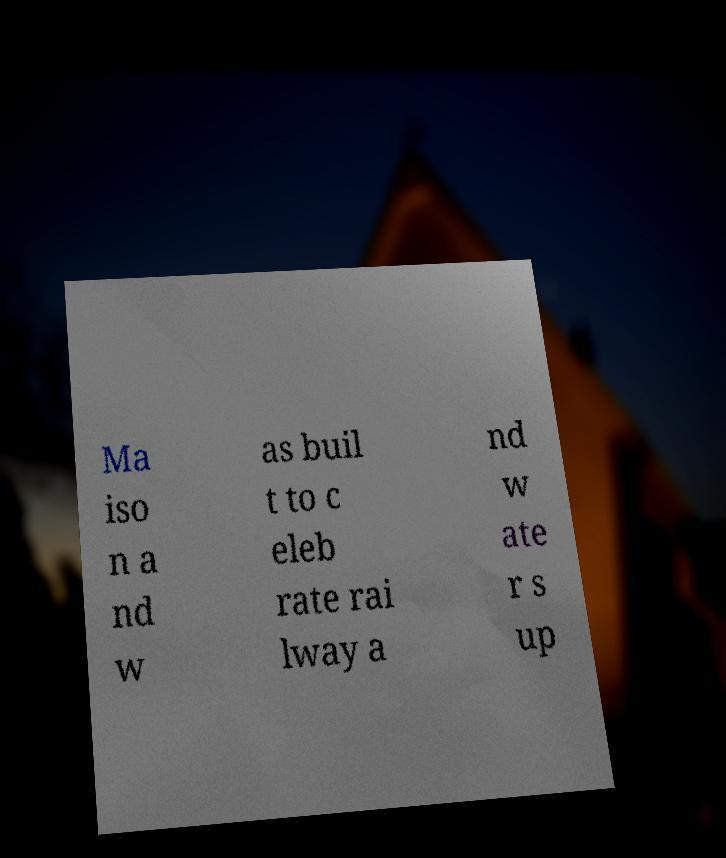Please identify and transcribe the text found in this image. Ma iso n a nd w as buil t to c eleb rate rai lway a nd w ate r s up 